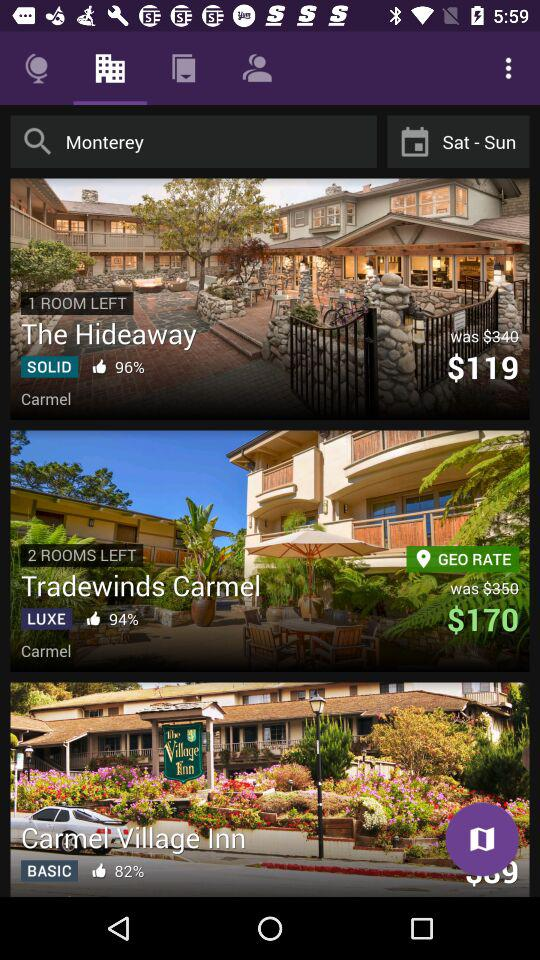What is the price for "Tradewinds Carmel"? The price is $170. 